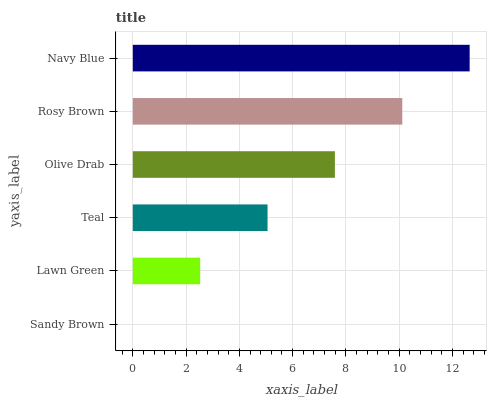Is Sandy Brown the minimum?
Answer yes or no. Yes. Is Navy Blue the maximum?
Answer yes or no. Yes. Is Lawn Green the minimum?
Answer yes or no. No. Is Lawn Green the maximum?
Answer yes or no. No. Is Lawn Green greater than Sandy Brown?
Answer yes or no. Yes. Is Sandy Brown less than Lawn Green?
Answer yes or no. Yes. Is Sandy Brown greater than Lawn Green?
Answer yes or no. No. Is Lawn Green less than Sandy Brown?
Answer yes or no. No. Is Olive Drab the high median?
Answer yes or no. Yes. Is Teal the low median?
Answer yes or no. Yes. Is Teal the high median?
Answer yes or no. No. Is Sandy Brown the low median?
Answer yes or no. No. 